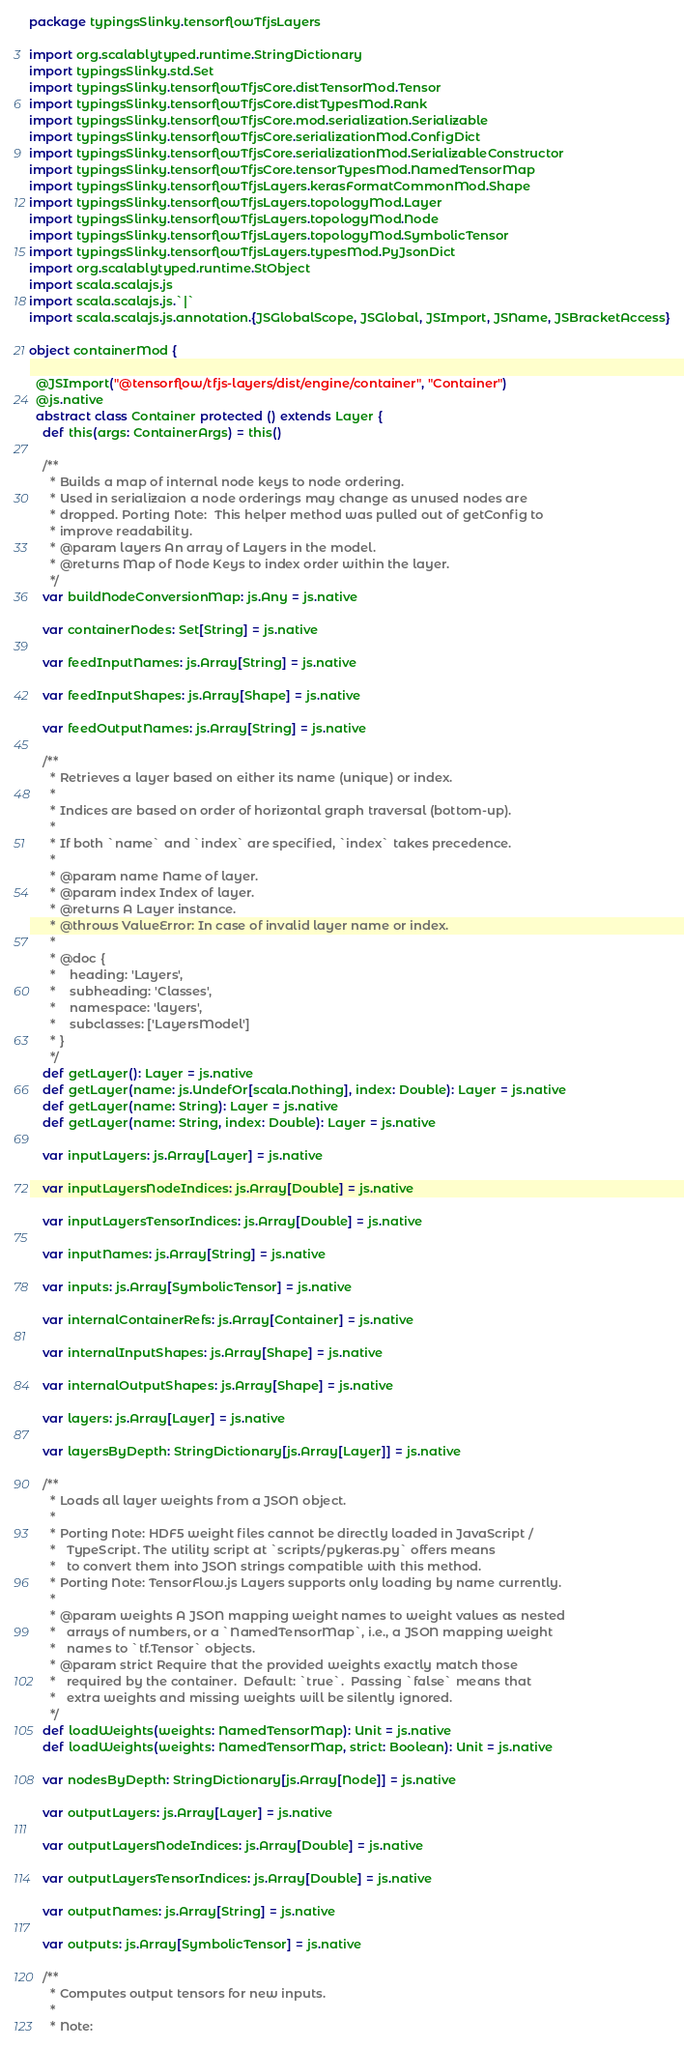Convert code to text. <code><loc_0><loc_0><loc_500><loc_500><_Scala_>package typingsSlinky.tensorflowTfjsLayers

import org.scalablytyped.runtime.StringDictionary
import typingsSlinky.std.Set
import typingsSlinky.tensorflowTfjsCore.distTensorMod.Tensor
import typingsSlinky.tensorflowTfjsCore.distTypesMod.Rank
import typingsSlinky.tensorflowTfjsCore.mod.serialization.Serializable
import typingsSlinky.tensorflowTfjsCore.serializationMod.ConfigDict
import typingsSlinky.tensorflowTfjsCore.serializationMod.SerializableConstructor
import typingsSlinky.tensorflowTfjsCore.tensorTypesMod.NamedTensorMap
import typingsSlinky.tensorflowTfjsLayers.kerasFormatCommonMod.Shape
import typingsSlinky.tensorflowTfjsLayers.topologyMod.Layer
import typingsSlinky.tensorflowTfjsLayers.topologyMod.Node
import typingsSlinky.tensorflowTfjsLayers.topologyMod.SymbolicTensor
import typingsSlinky.tensorflowTfjsLayers.typesMod.PyJsonDict
import org.scalablytyped.runtime.StObject
import scala.scalajs.js
import scala.scalajs.js.`|`
import scala.scalajs.js.annotation.{JSGlobalScope, JSGlobal, JSImport, JSName, JSBracketAccess}

object containerMod {
  
  @JSImport("@tensorflow/tfjs-layers/dist/engine/container", "Container")
  @js.native
  abstract class Container protected () extends Layer {
    def this(args: ContainerArgs) = this()
    
    /**
      * Builds a map of internal node keys to node ordering.
      * Used in serializaion a node orderings may change as unused nodes are
      * dropped. Porting Note:  This helper method was pulled out of getConfig to
      * improve readability.
      * @param layers An array of Layers in the model.
      * @returns Map of Node Keys to index order within the layer.
      */
    var buildNodeConversionMap: js.Any = js.native
    
    var containerNodes: Set[String] = js.native
    
    var feedInputNames: js.Array[String] = js.native
    
    var feedInputShapes: js.Array[Shape] = js.native
    
    var feedOutputNames: js.Array[String] = js.native
    
    /**
      * Retrieves a layer based on either its name (unique) or index.
      *
      * Indices are based on order of horizontal graph traversal (bottom-up).
      *
      * If both `name` and `index` are specified, `index` takes precedence.
      *
      * @param name Name of layer.
      * @param index Index of layer.
      * @returns A Layer instance.
      * @throws ValueError: In case of invalid layer name or index.
      *
      * @doc {
      *    heading: 'Layers',
      *    subheading: 'Classes',
      *    namespace: 'layers',
      *    subclasses: ['LayersModel']
      * }
      */
    def getLayer(): Layer = js.native
    def getLayer(name: js.UndefOr[scala.Nothing], index: Double): Layer = js.native
    def getLayer(name: String): Layer = js.native
    def getLayer(name: String, index: Double): Layer = js.native
    
    var inputLayers: js.Array[Layer] = js.native
    
    var inputLayersNodeIndices: js.Array[Double] = js.native
    
    var inputLayersTensorIndices: js.Array[Double] = js.native
    
    var inputNames: js.Array[String] = js.native
    
    var inputs: js.Array[SymbolicTensor] = js.native
    
    var internalContainerRefs: js.Array[Container] = js.native
    
    var internalInputShapes: js.Array[Shape] = js.native
    
    var internalOutputShapes: js.Array[Shape] = js.native
    
    var layers: js.Array[Layer] = js.native
    
    var layersByDepth: StringDictionary[js.Array[Layer]] = js.native
    
    /**
      * Loads all layer weights from a JSON object.
      *
      * Porting Note: HDF5 weight files cannot be directly loaded in JavaScript /
      *   TypeScript. The utility script at `scripts/pykeras.py` offers means
      *   to convert them into JSON strings compatible with this method.
      * Porting Note: TensorFlow.js Layers supports only loading by name currently.
      *
      * @param weights A JSON mapping weight names to weight values as nested
      *   arrays of numbers, or a `NamedTensorMap`, i.e., a JSON mapping weight
      *   names to `tf.Tensor` objects.
      * @param strict Require that the provided weights exactly match those
      *   required by the container.  Default: `true`.  Passing `false` means that
      *   extra weights and missing weights will be silently ignored.
      */
    def loadWeights(weights: NamedTensorMap): Unit = js.native
    def loadWeights(weights: NamedTensorMap, strict: Boolean): Unit = js.native
    
    var nodesByDepth: StringDictionary[js.Array[Node]] = js.native
    
    var outputLayers: js.Array[Layer] = js.native
    
    var outputLayersNodeIndices: js.Array[Double] = js.native
    
    var outputLayersTensorIndices: js.Array[Double] = js.native
    
    var outputNames: js.Array[String] = js.native
    
    var outputs: js.Array[SymbolicTensor] = js.native
    
    /**
      * Computes output tensors for new inputs.
      *
      * Note:</code> 